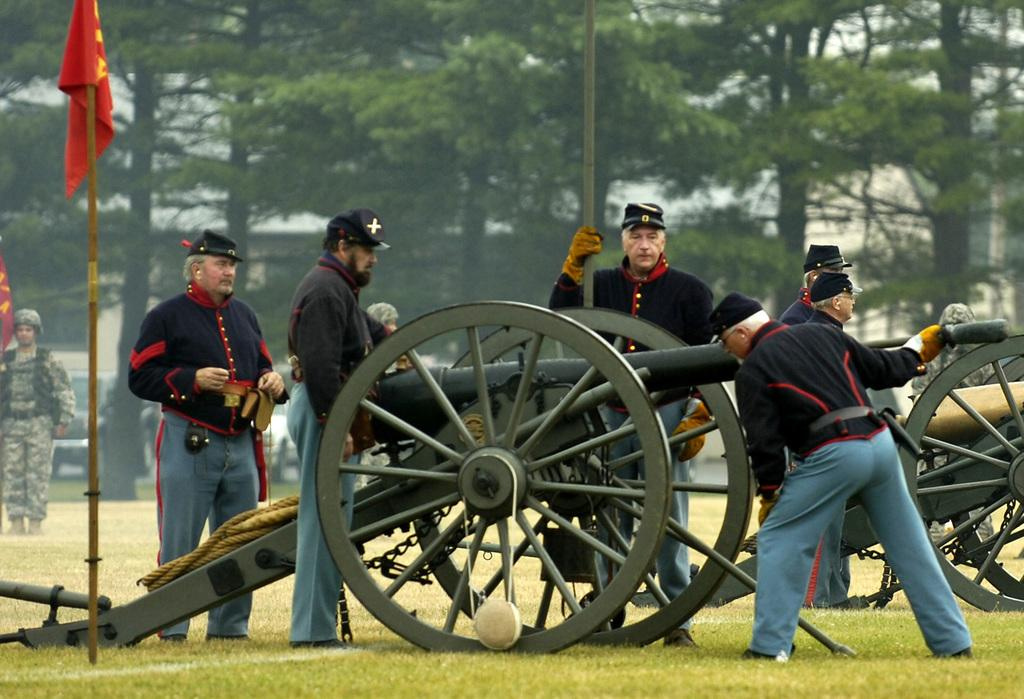What can be seen in the image involving people? There are people standing in the image. What type of ground surface is visible at the bottom of the image? There is grass at the bottom of the image. What is the object with a specific design or pattern in the image? There is a flag in the image. What type of vegetation is present in the background of the image? There are trees in the background of the image. What is the long, flexible object visible in the image? There is a rope visible in the image. What type of leather material can be seen on the people in the image? There is no leather material visible on the people in the image. How many hearts are present in the image? There are no hearts visible in the image. 